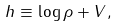<formula> <loc_0><loc_0><loc_500><loc_500>h \equiv \log \rho + V ,</formula> 